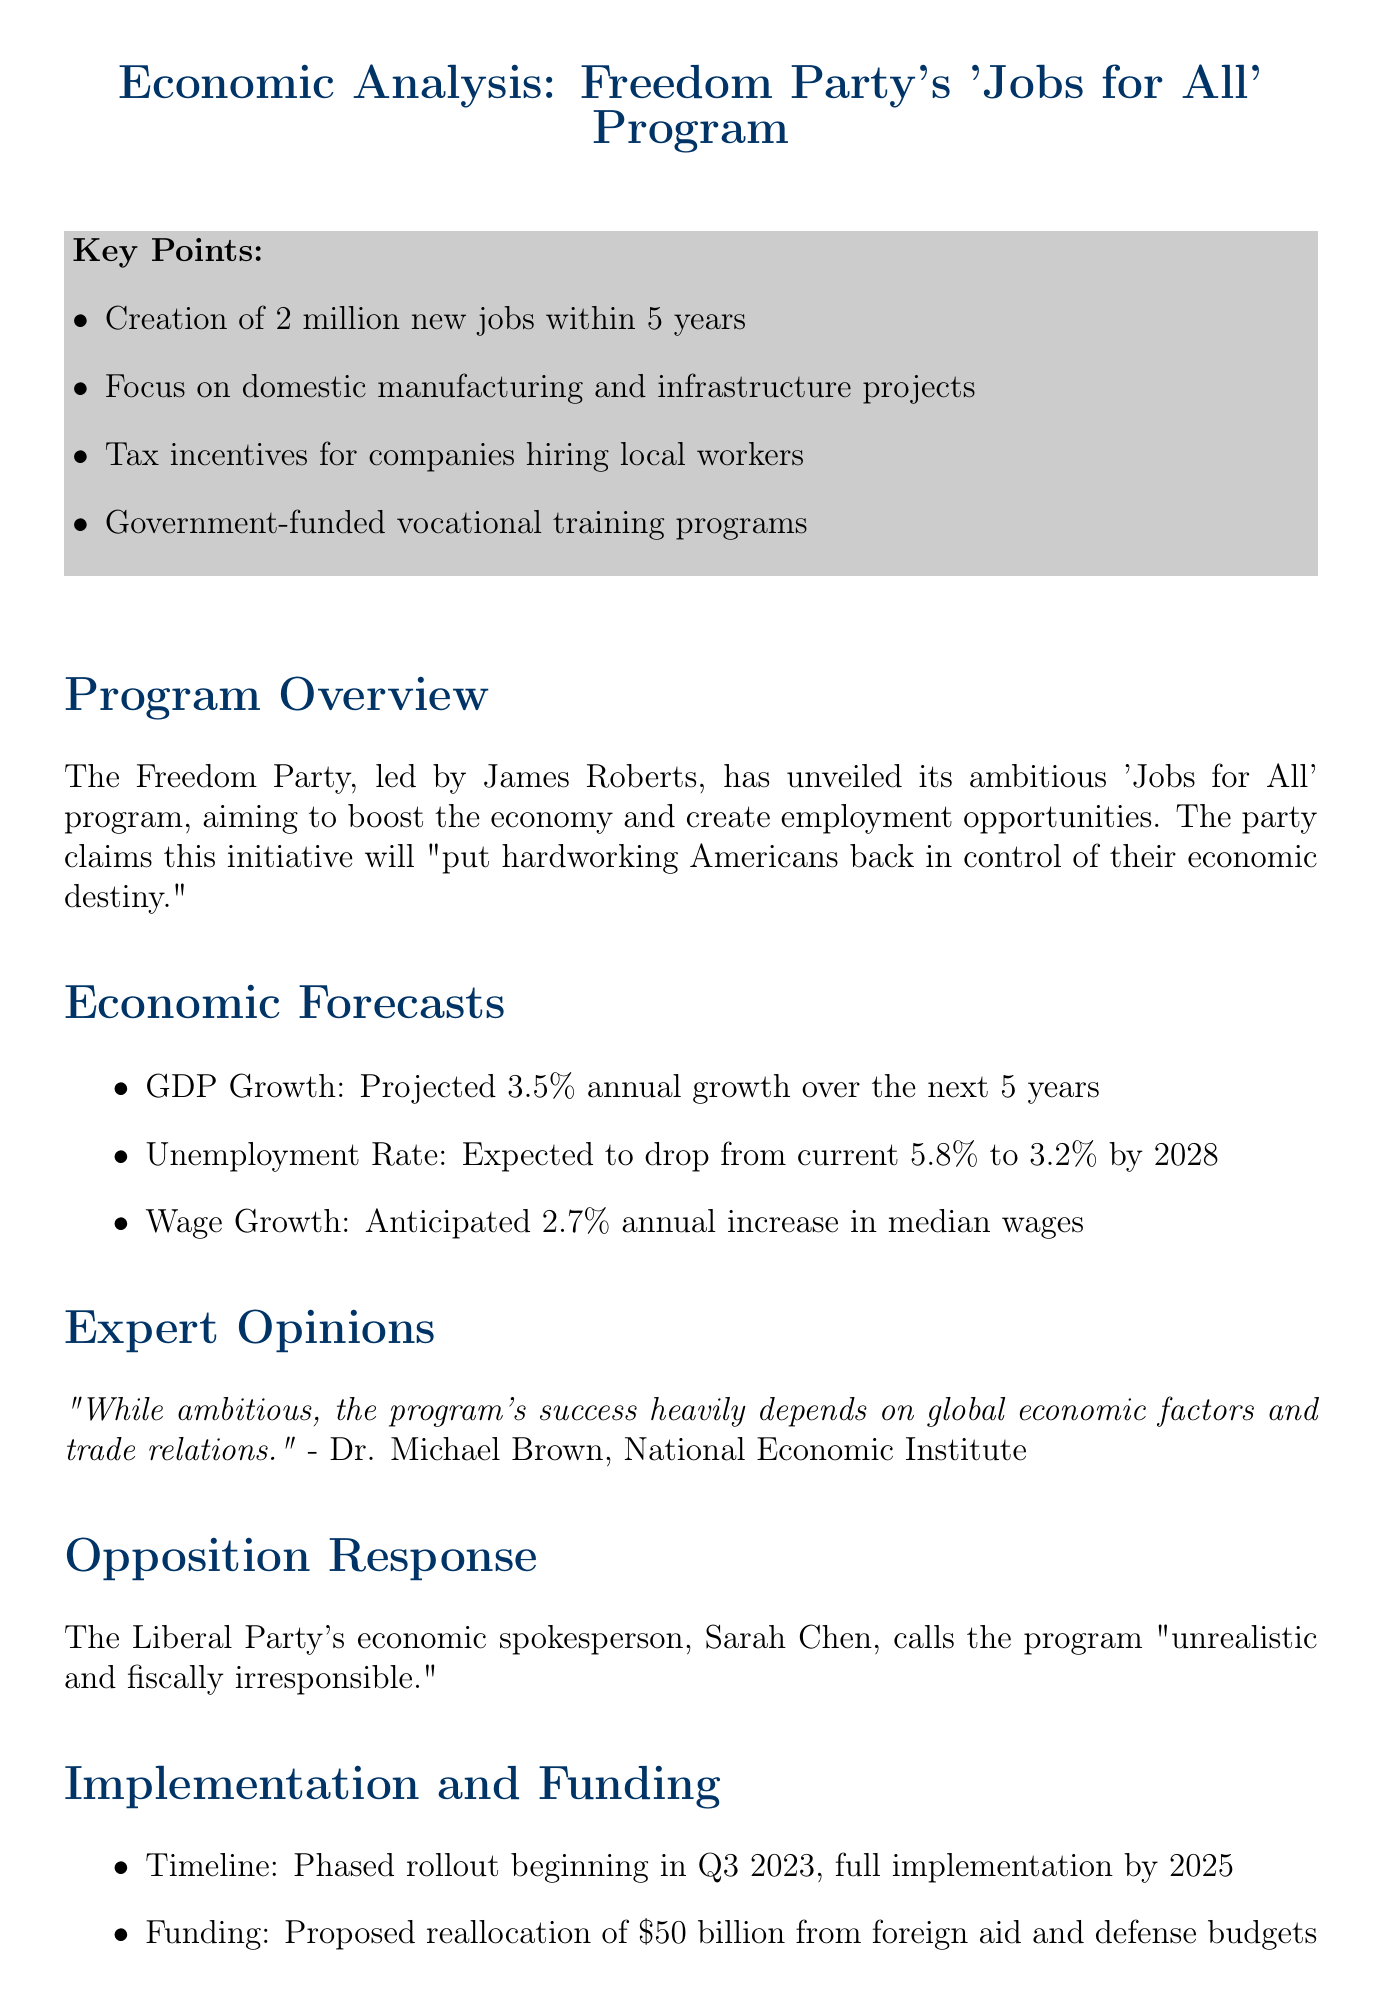What is the name of the program? The name of the program is found in the document, specifically titled 'Jobs for All'.
Answer: Jobs for All Who is the leader of the Freedom Party? The leader of the Freedom Party is mentioned at the beginning of the document.
Answer: James Roberts How many new jobs does the program propose to create? The document states the program aims to create 2 million new jobs within 5 years.
Answer: 2 million What is the projected unemployment rate by 2028? The projected unemployment rate is included in the economic forecasts section of the document.
Answer: 3.2% What is the source of funding for the program? The document outlines the funding source as a proposed reallocation from specific budgets.
Answer: $50 billion from foreign aid and defense budgets Which economist commented on the program? The document provides a quote from an independent economist regarding the program's success factors.
Answer: Dr. Michael Brown What is the public support percentage for the program's goals? The public opinion section reveals the percentage of voters supporting the program.
Answer: 62% What is the timeline for full implementation of the program? The document specifies a phased rollout beginning in Q3 2023, detailing the full implementation timeline.
Answer: By 2025 What did the opposition's spokesperson call the program? The opposition's response section in the document quotes their spokesperson's description of the program.
Answer: Unrealistic and fiscally irresponsible 